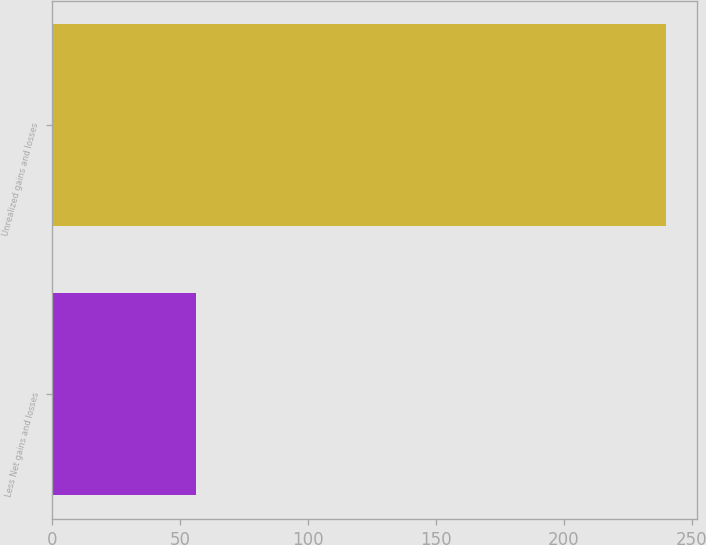Convert chart to OTSL. <chart><loc_0><loc_0><loc_500><loc_500><bar_chart><fcel>Less Net gains and losses<fcel>Unrealized gains and losses<nl><fcel>56<fcel>240<nl></chart> 